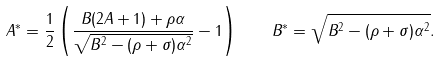Convert formula to latex. <formula><loc_0><loc_0><loc_500><loc_500>A ^ { * } = \frac { 1 } { 2 } \left ( \frac { B ( 2 A + 1 ) + \rho \alpha } { \sqrt { B ^ { 2 } - ( \rho + \sigma ) \alpha ^ { 2 } } } - 1 \right ) \quad B ^ { * } = \sqrt { B ^ { 2 } - ( \rho + \sigma ) \alpha ^ { 2 } } .</formula> 